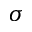Convert formula to latex. <formula><loc_0><loc_0><loc_500><loc_500>\sigma</formula> 